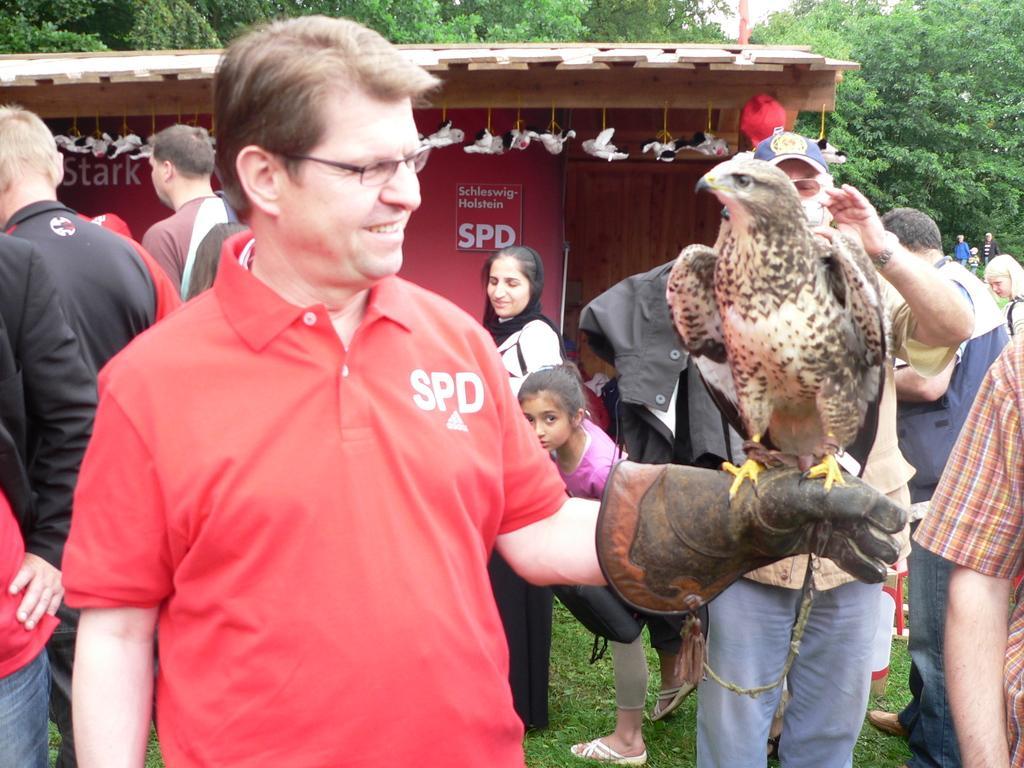Could you give a brief overview of what you see in this image? In this picture there is a man who is wearing spectacle, t-shirt and gloves. On his gloves there is an eagle who is standing. On the left there are two persons are wearing the same dress. On the right there is a man who is standing behind the eagle. In the back there is a woman who is standing near to the shade. In the background i can see many trees. At the top there is a sky. 